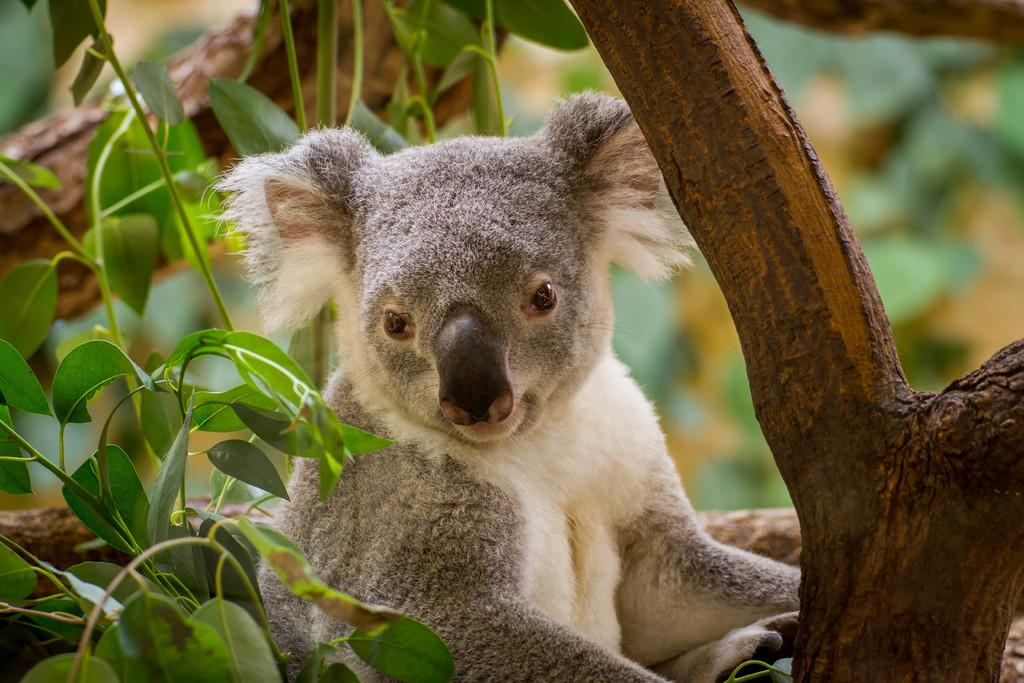What type of plant can be seen in the image? There is a tree with leaves in the image. Is there any wildlife present in the image? Yes, there is an animal sitting on the tree. What type of cows can be seen on the voyage in the image? There are no cows or voyages present in the image; it features a tree with leaves and an animal sitting on it. What type of thunder can be heard in the image? There is no thunder present in the image, as it is a still image and does not contain any sound. 